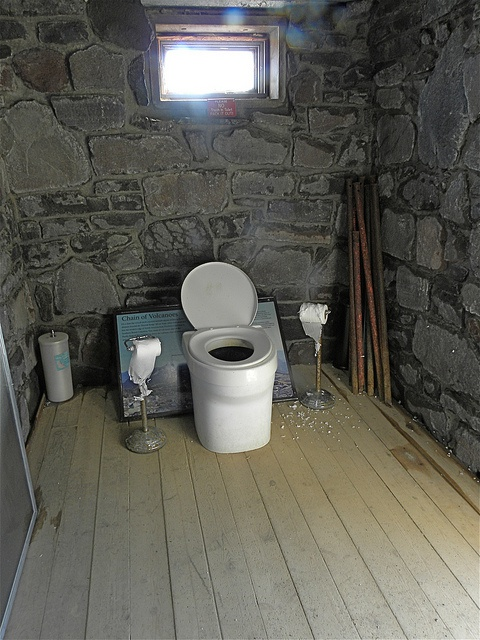Describe the objects in this image and their specific colors. I can see a toilet in black, darkgray, lightgray, and gray tones in this image. 